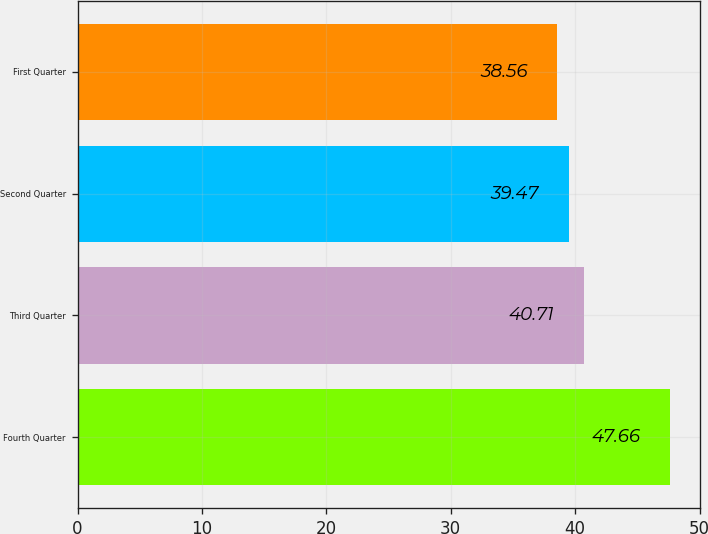Convert chart. <chart><loc_0><loc_0><loc_500><loc_500><bar_chart><fcel>Fourth Quarter<fcel>Third Quarter<fcel>Second Quarter<fcel>First Quarter<nl><fcel>47.66<fcel>40.71<fcel>39.47<fcel>38.56<nl></chart> 